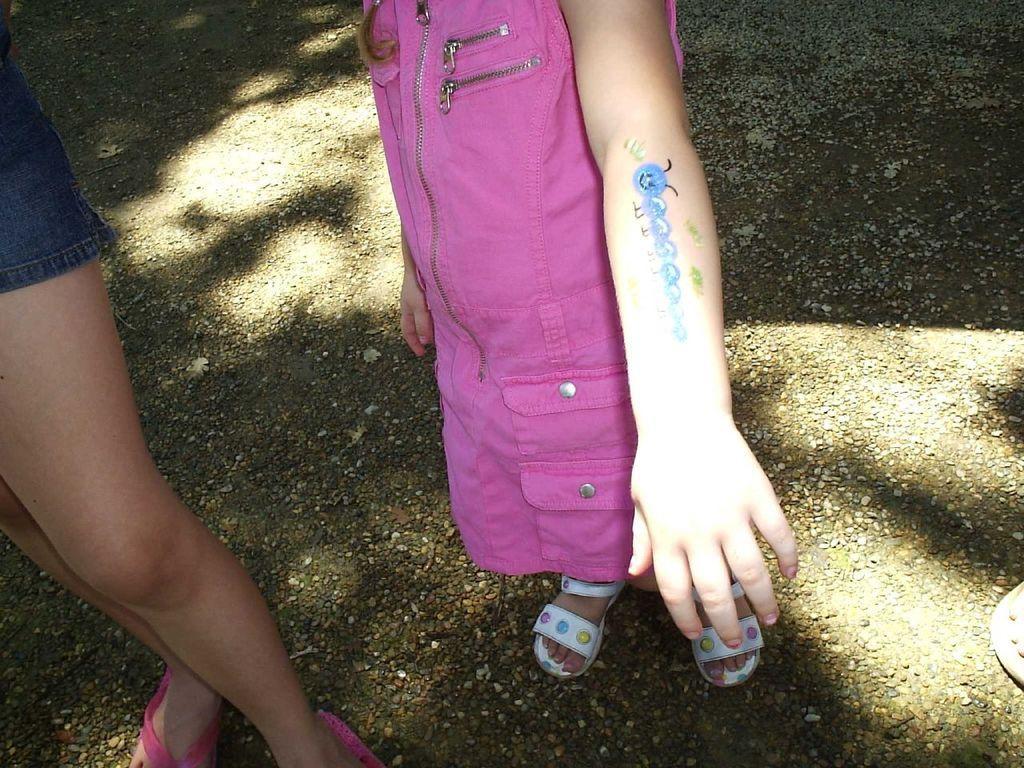How would you summarize this image in a sentence or two? On the right side, there is a person in a shirt wearing pink color slippers standing on the road near a child who is in pink color dress and is standing on the road. On the right side, there is a person who is wearing slipper standing on the road on which, there are small stones and shadows of some objects. 